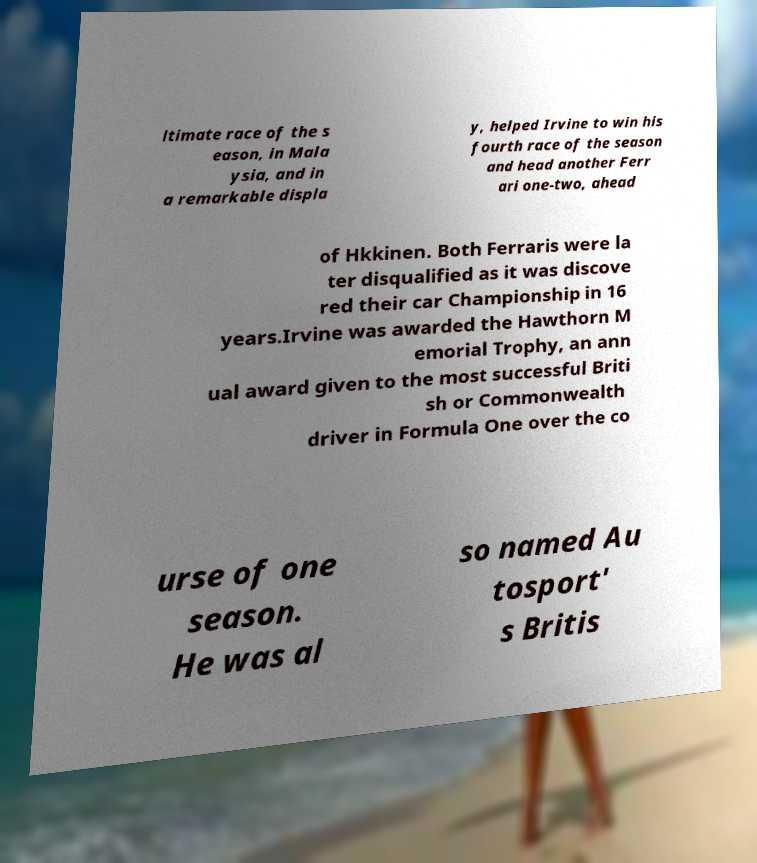What messages or text are displayed in this image? I need them in a readable, typed format. ltimate race of the s eason, in Mala ysia, and in a remarkable displa y, helped Irvine to win his fourth race of the season and head another Ferr ari one-two, ahead of Hkkinen. Both Ferraris were la ter disqualified as it was discove red their car Championship in 16 years.Irvine was awarded the Hawthorn M emorial Trophy, an ann ual award given to the most successful Briti sh or Commonwealth driver in Formula One over the co urse of one season. He was al so named Au tosport' s Britis 